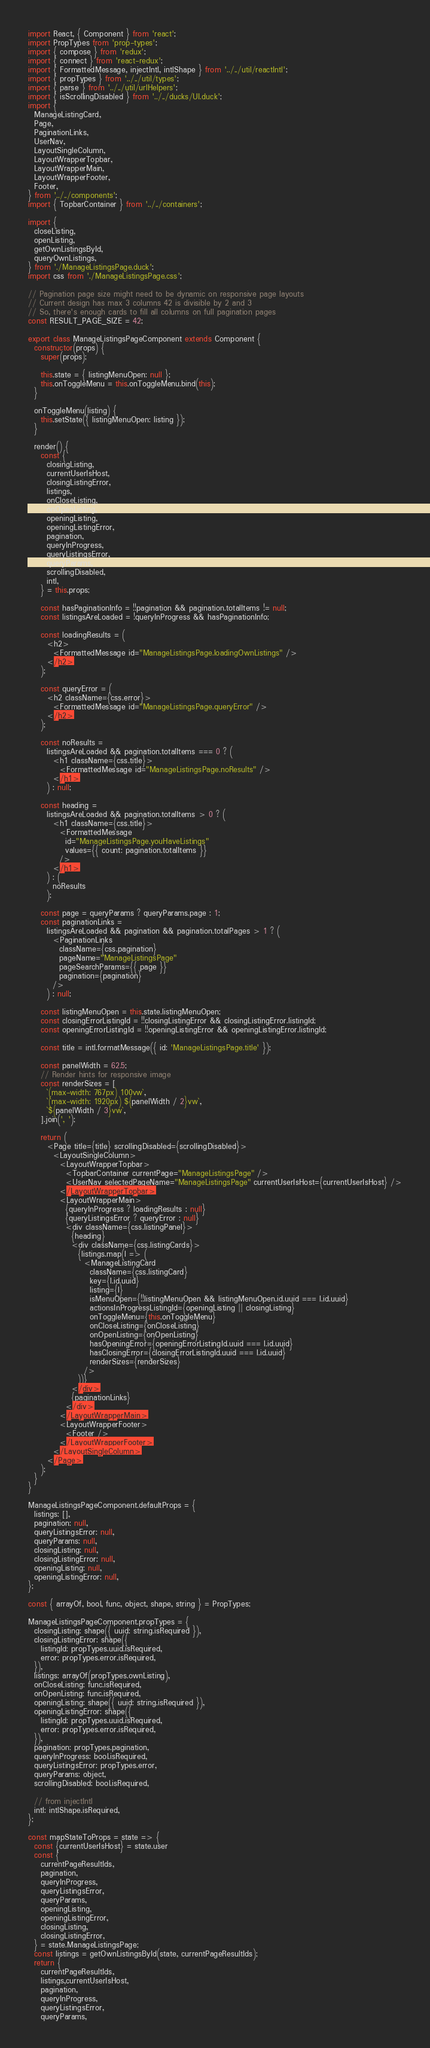<code> <loc_0><loc_0><loc_500><loc_500><_JavaScript_>import React, { Component } from 'react';
import PropTypes from 'prop-types';
import { compose } from 'redux';
import { connect } from 'react-redux';
import { FormattedMessage, injectIntl, intlShape } from '../../util/reactIntl';
import { propTypes } from '../../util/types';
import { parse } from '../../util/urlHelpers';
import { isScrollingDisabled } from '../../ducks/UI.duck';
import {
  ManageListingCard,
  Page,
  PaginationLinks,
  UserNav,
  LayoutSingleColumn,
  LayoutWrapperTopbar,
  LayoutWrapperMain,
  LayoutWrapperFooter,
  Footer,
} from '../../components';
import { TopbarContainer } from '../../containers';

import {
  closeListing,
  openListing,
  getOwnListingsById,
  queryOwnListings,
} from './ManageListingsPage.duck';
import css from './ManageListingsPage.css';

// Pagination page size might need to be dynamic on responsive page layouts
// Current design has max 3 columns 42 is divisible by 2 and 3
// So, there's enough cards to fill all columns on full pagination pages
const RESULT_PAGE_SIZE = 42;

export class ManageListingsPageComponent extends Component {
  constructor(props) {
    super(props);

    this.state = { listingMenuOpen: null };
    this.onToggleMenu = this.onToggleMenu.bind(this);
  }

  onToggleMenu(listing) {
    this.setState({ listingMenuOpen: listing });
  }

  render() {
    const {
      closingListing,
      currentUserIsHost,
      closingListingError,
      listings,
      onCloseListing,
      onOpenListing,
      openingListing,
      openingListingError,
      pagination,
      queryInProgress,
      queryListingsError,
      queryParams,
      scrollingDisabled,
      intl,
    } = this.props;

    const hasPaginationInfo = !!pagination && pagination.totalItems != null;
    const listingsAreLoaded = !queryInProgress && hasPaginationInfo;

    const loadingResults = (
      <h2>
        <FormattedMessage id="ManageListingsPage.loadingOwnListings" />
      </h2>
    );

    const queryError = (
      <h2 className={css.error}>
        <FormattedMessage id="ManageListingsPage.queryError" />
      </h2>
    );

    const noResults =
      listingsAreLoaded && pagination.totalItems === 0 ? (
        <h1 className={css.title}>
          <FormattedMessage id="ManageListingsPage.noResults" />
        </h1>
      ) : null;

    const heading =
      listingsAreLoaded && pagination.totalItems > 0 ? (
        <h1 className={css.title}>
          <FormattedMessage
            id="ManageListingsPage.youHaveListings"
            values={{ count: pagination.totalItems }}
          />
        </h1>
      ) : (
        noResults
      );

    const page = queryParams ? queryParams.page : 1;
    const paginationLinks =
      listingsAreLoaded && pagination && pagination.totalPages > 1 ? (
        <PaginationLinks
          className={css.pagination}
          pageName="ManageListingsPage"
          pageSearchParams={{ page }}
          pagination={pagination}
        />
      ) : null;

    const listingMenuOpen = this.state.listingMenuOpen;
    const closingErrorListingId = !!closingListingError && closingListingError.listingId;
    const openingErrorListingId = !!openingListingError && openingListingError.listingId;

    const title = intl.formatMessage({ id: 'ManageListingsPage.title' });

    const panelWidth = 62.5;
    // Render hints for responsive image
    const renderSizes = [
      `(max-width: 767px) 100vw`,
      `(max-width: 1920px) ${panelWidth / 2}vw`,
      `${panelWidth / 3}vw`,
    ].join(', ');

    return (
      <Page title={title} scrollingDisabled={scrollingDisabled}>
        <LayoutSingleColumn>
          <LayoutWrapperTopbar>
            <TopbarContainer currentPage="ManageListingsPage" />
            <UserNav selectedPageName="ManageListingsPage" currentUserIsHost={currentUserIsHost} />
          </LayoutWrapperTopbar>
          <LayoutWrapperMain>
            {queryInProgress ? loadingResults : null}
            {queryListingsError ? queryError : null}
            <div className={css.listingPanel}>
              {heading}
              <div className={css.listingCards}>
                {listings.map(l => (
                  <ManageListingCard
                    className={css.listingCard}
                    key={l.id.uuid}
                    listing={l}
                    isMenuOpen={!!listingMenuOpen && listingMenuOpen.id.uuid === l.id.uuid}
                    actionsInProgressListingId={openingListing || closingListing}
                    onToggleMenu={this.onToggleMenu}
                    onCloseListing={onCloseListing}
                    onOpenListing={onOpenListing}
                    hasOpeningError={openingErrorListingId.uuid === l.id.uuid}
                    hasClosingError={closingErrorListingId.uuid === l.id.uuid}
                    renderSizes={renderSizes}
                  />
                ))}
              </div>
              {paginationLinks}
            </div>
          </LayoutWrapperMain>
          <LayoutWrapperFooter>
            <Footer />
          </LayoutWrapperFooter>
        </LayoutSingleColumn>
      </Page>
    );
  }
}

ManageListingsPageComponent.defaultProps = {
  listings: [],
  pagination: null,
  queryListingsError: null,
  queryParams: null,
  closingListing: null,
  closingListingError: null,
  openingListing: null,
  openingListingError: null,
};

const { arrayOf, bool, func, object, shape, string } = PropTypes;

ManageListingsPageComponent.propTypes = {
  closingListing: shape({ uuid: string.isRequired }),
  closingListingError: shape({
    listingId: propTypes.uuid.isRequired,
    error: propTypes.error.isRequired,
  }),
  listings: arrayOf(propTypes.ownListing),
  onCloseListing: func.isRequired,
  onOpenListing: func.isRequired,
  openingListing: shape({ uuid: string.isRequired }),
  openingListingError: shape({
    listingId: propTypes.uuid.isRequired,
    error: propTypes.error.isRequired,
  }),
  pagination: propTypes.pagination,
  queryInProgress: bool.isRequired,
  queryListingsError: propTypes.error,
  queryParams: object,
  scrollingDisabled: bool.isRequired,

  // from injectIntl
  intl: intlShape.isRequired,
};

const mapStateToProps = state => {
  const {currentUserIsHost} = state.user
  const {
    currentPageResultIds,
    pagination,
    queryInProgress,
    queryListingsError,
    queryParams,
    openingListing,
    openingListingError,
    closingListing,
    closingListingError,
  } = state.ManageListingsPage;
  const listings = getOwnListingsById(state, currentPageResultIds);
  return {
    currentPageResultIds,
    listings,currentUserIsHost,
    pagination,
    queryInProgress,
    queryListingsError,
    queryParams,</code> 